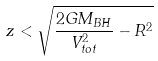Convert formula to latex. <formula><loc_0><loc_0><loc_500><loc_500>z < \sqrt { \frac { 2 G M _ { B H } } { V _ { t o t } ^ { 2 } } - R ^ { 2 } }</formula> 